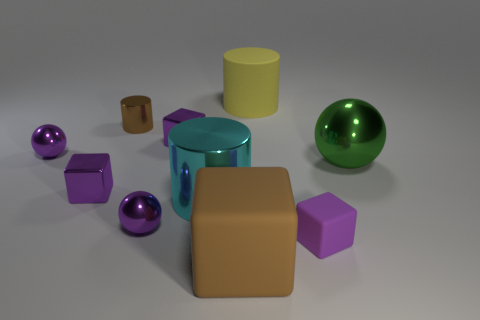There is a large object that is the same color as the tiny metallic cylinder; what is its material?
Your answer should be very brief. Rubber. There is another large metal object that is the same shape as the brown metallic thing; what is its color?
Your answer should be compact. Cyan. How many shiny things are either large yellow things or cubes?
Provide a short and direct response. 2. There is a large matte thing that is behind the cube to the right of the big rubber cylinder; are there any big yellow objects on the right side of it?
Your answer should be very brief. No. What is the color of the large rubber cylinder?
Make the answer very short. Yellow. There is a metal object in front of the large cyan metal object; is it the same shape as the big green thing?
Keep it short and to the point. Yes. What number of things are either big purple blocks or things that are behind the big cyan shiny object?
Keep it short and to the point. 6. Is the big cylinder that is left of the big yellow cylinder made of the same material as the green thing?
Ensure brevity in your answer.  Yes. Is there any other thing that has the same size as the purple rubber cube?
Give a very brief answer. Yes. What is the material of the cube that is on the left side of the tiny purple metal object that is in front of the cyan thing?
Ensure brevity in your answer.  Metal. 